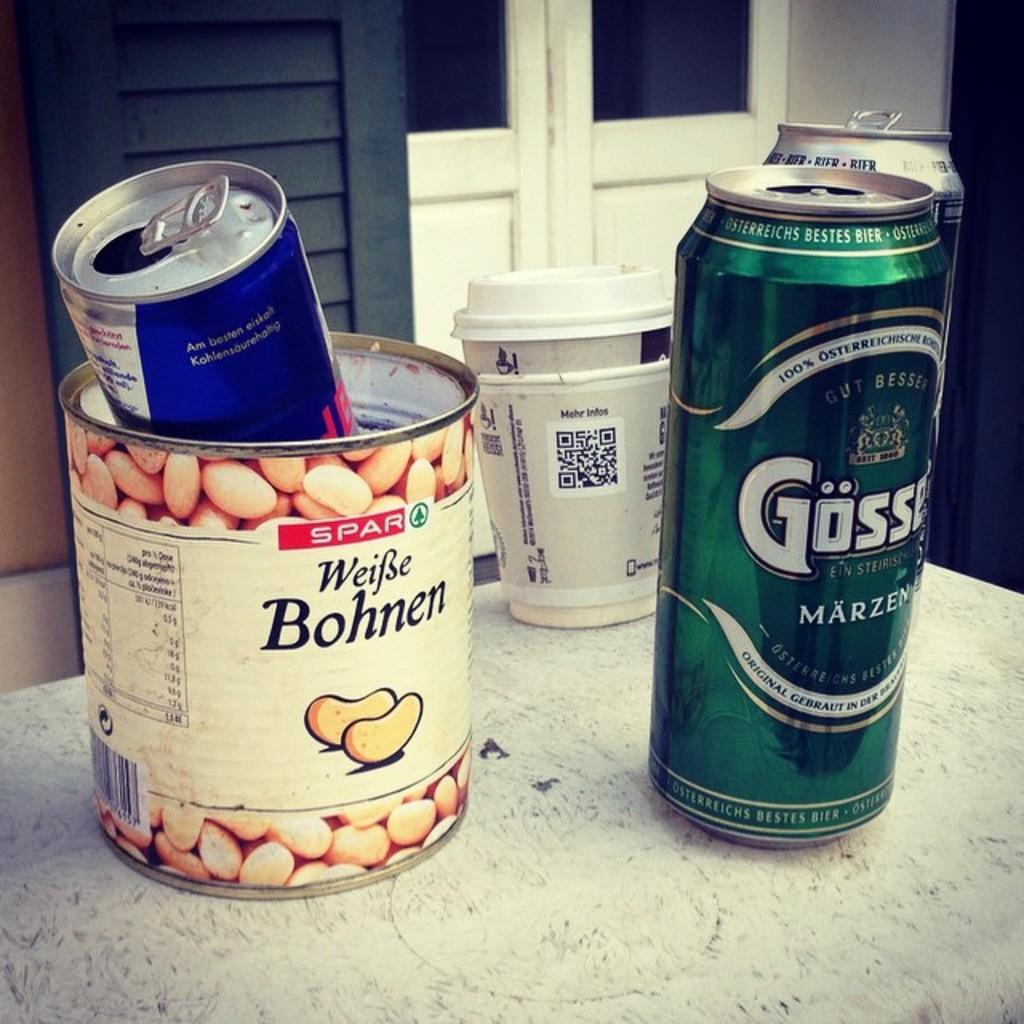<image>
Describe the image concisely. A empty can of beans with a red bull can in it sits next to a green beer can and used paper coffee cup. 